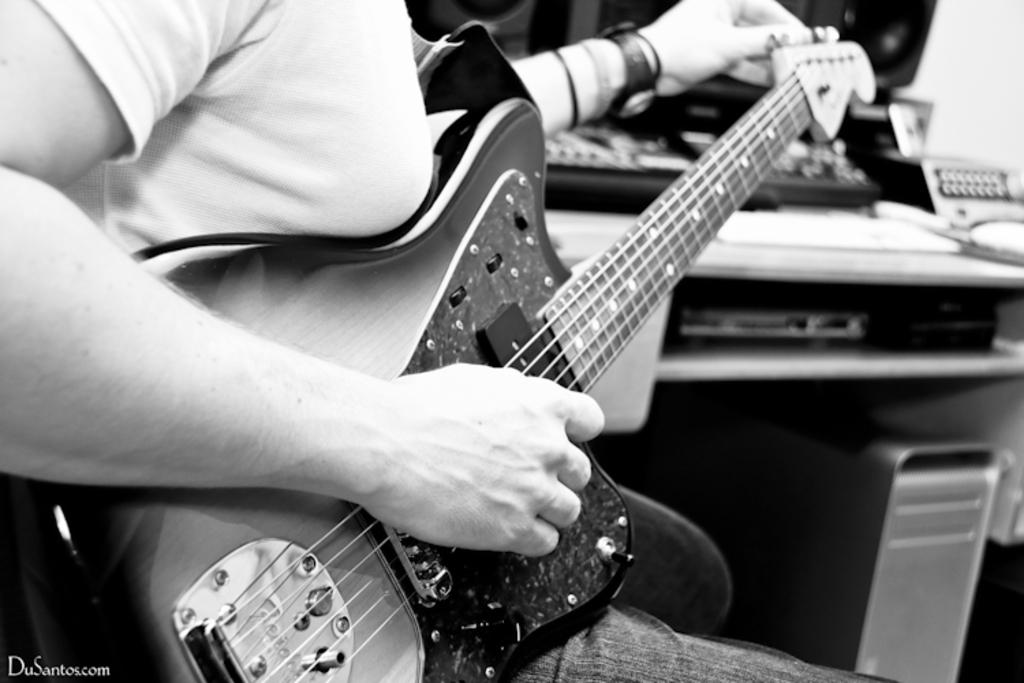What is the person in the image doing? The person is holding a guitar. What object is the person holding in the image? The person is holding a guitar. What can be seen on the right side of the image? There is a table on the right side of the image. What is on the table in the image? There are objects placed on the table. What letter is the person writing on the page in the image? There is no page or letter present in the image; the person is holding a guitar. 